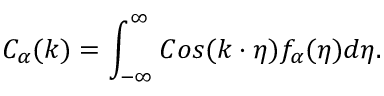Convert formula to latex. <formula><loc_0><loc_0><loc_500><loc_500>C _ { \alpha } ( k ) = \int _ { - \infty } ^ { \infty } C o s ( k \cdot \eta ) f _ { \alpha } ( \eta ) d \eta .</formula> 